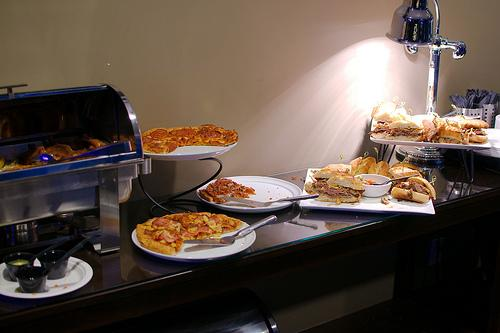Create a narrative about the image, highlighting the importance of the warming light. As guests eagerly gathered around the mouthwatering spread of pizza and sandwiches, they marveled at how each dish remained steaming hot. High above the table, a subtle warming light worked its magic, ensuring that every guest would experience the satisfaction of a perfect bite. Identify the main objects on the table in the image. There are plates of pizza, sandwiches, white plates, bowls with sauces, black condiment cups, and a metal serving utensil on the table. In the multi-choice VQA task, what could be an example question and answer related to the image and its captions? Answer: Pizza and sandwiches Explain the environment where the food is being served. The food is served on a glass countertop, and there is a warming tool for the food, as well as a warming light above the sandwiches. Describe an advertisement promoting the food shown in the image. Enjoy delicious pizzas and scrumptious sandwiches served fresh, hot, and ready to enjoy! Our warming tools keep each bite tasty, while our stylish glass countertop and white plates create a visually appealing presentation. Don't miss out on this delightful dining experience! Write a sentence using a descriptive language style about one of the objects in the image. The sumptuously garnished pizza, nestled on a pristine white plate, entices the onlooker with its visually tantalizing presentation. What kind of food is primarily featured in the image? The image primarily features plates of pizza and sandwiches on a table. 